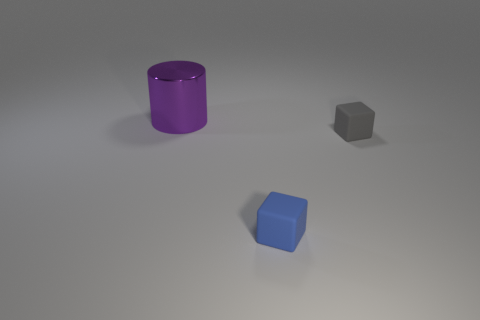Add 2 big purple things. How many objects exist? 5 Subtract all blue cubes. How many cubes are left? 1 Subtract 1 blocks. How many blocks are left? 1 Subtract all cylinders. How many objects are left? 2 Subtract all blue cylinders. Subtract all purple blocks. How many cylinders are left? 1 Subtract all tiny blue rubber blocks. Subtract all small blue blocks. How many objects are left? 1 Add 1 small blue objects. How many small blue objects are left? 2 Add 1 blue things. How many blue things exist? 2 Subtract 0 yellow spheres. How many objects are left? 3 